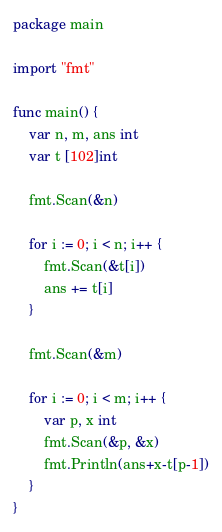Convert code to text. <code><loc_0><loc_0><loc_500><loc_500><_Go_>package main

import "fmt"

func main() {
    var n, m, ans int
    var t [102]int

    fmt.Scan(&n)

    for i := 0; i < n; i++ {
        fmt.Scan(&t[i])
        ans += t[i]
    }

    fmt.Scan(&m)

    for i := 0; i < m; i++ {
        var p, x int
        fmt.Scan(&p, &x)
        fmt.Println(ans+x-t[p-1])
    }
}</code> 